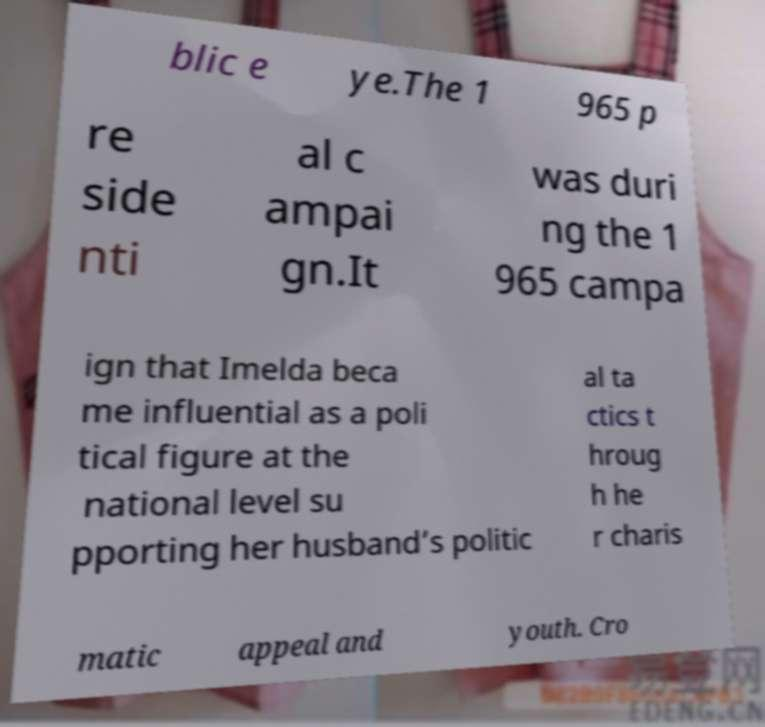Could you assist in decoding the text presented in this image and type it out clearly? blic e ye.The 1 965 p re side nti al c ampai gn.It was duri ng the 1 965 campa ign that Imelda beca me influential as a poli tical figure at the national level su pporting her husband’s politic al ta ctics t hroug h he r charis matic appeal and youth. Cro 